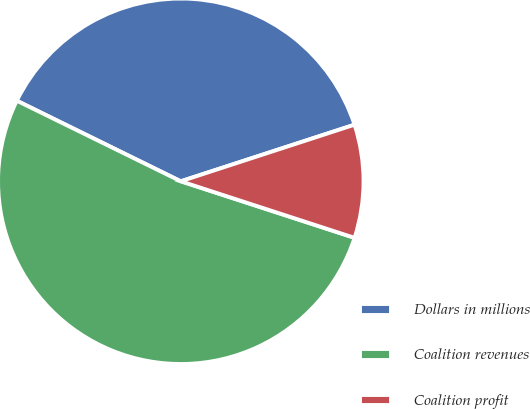<chart> <loc_0><loc_0><loc_500><loc_500><pie_chart><fcel>Dollars in millions<fcel>Coalition revenues<fcel>Coalition profit<nl><fcel>37.72%<fcel>52.26%<fcel>10.02%<nl></chart> 